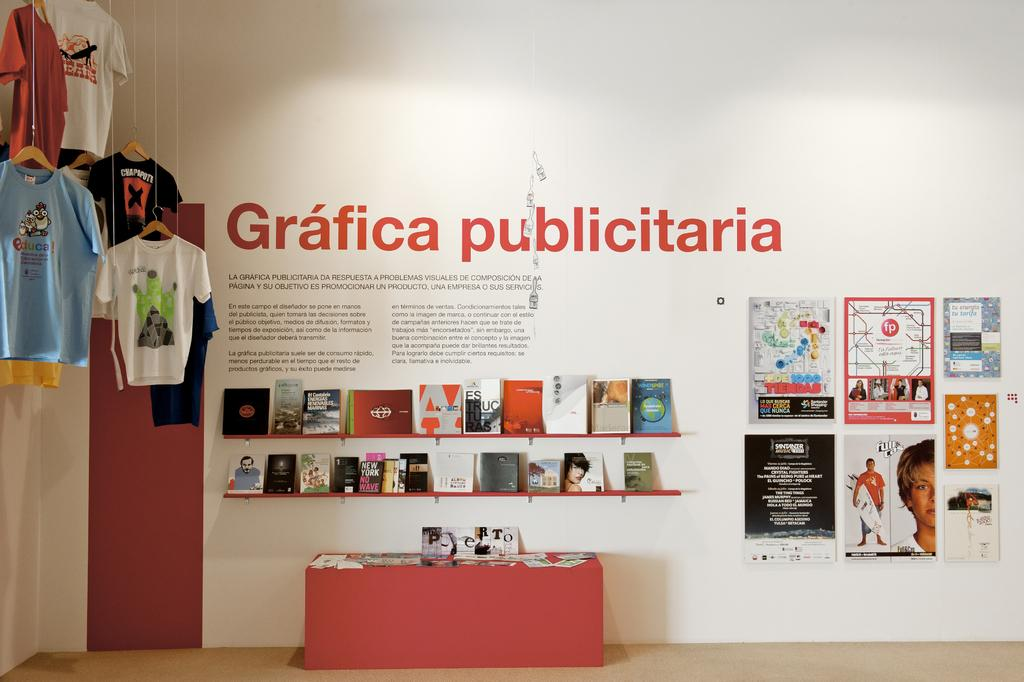Provide a one-sentence caption for the provided image. A display of merchandise with a Grafica Publicitaria sign behind it. 